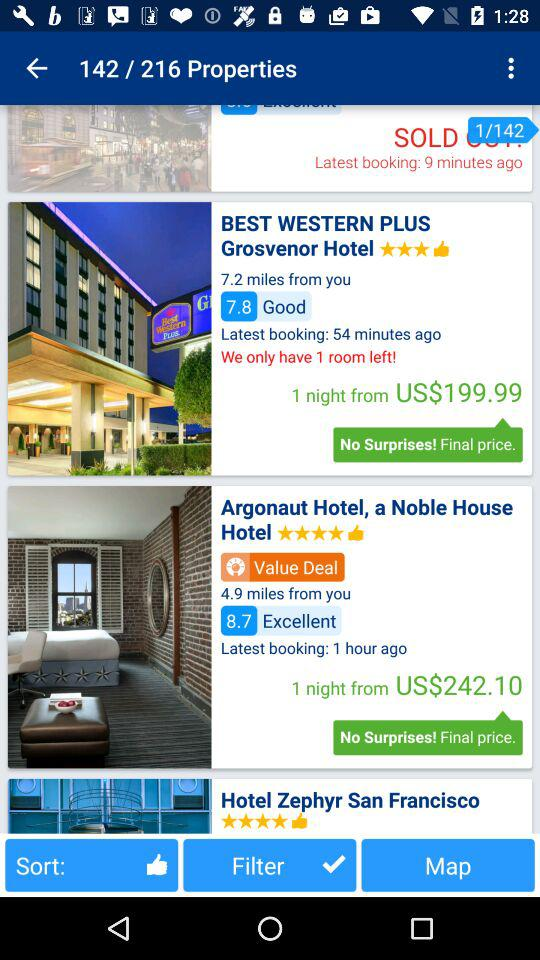What property number am I currently on? You are currently on property number 142. 